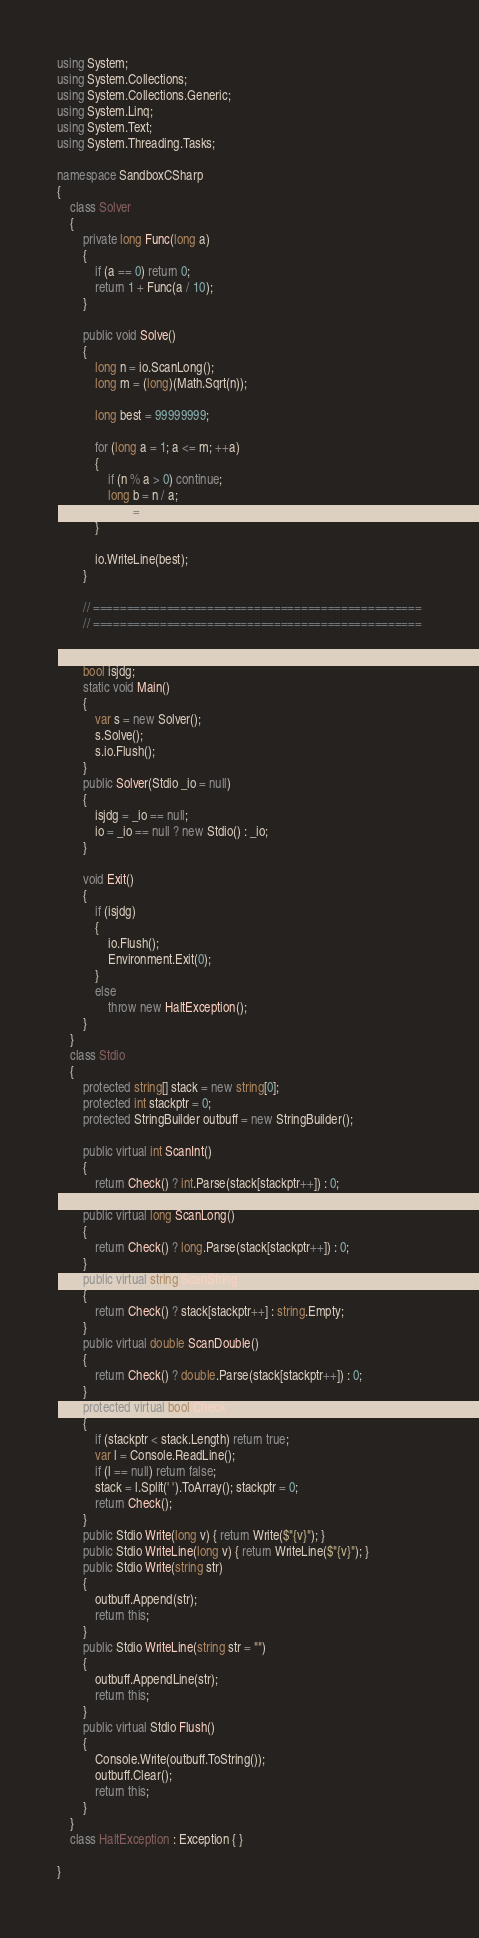<code> <loc_0><loc_0><loc_500><loc_500><_C#_>using System;
using System.Collections;
using System.Collections.Generic;
using System.Linq;
using System.Text;
using System.Threading.Tasks;

namespace SandboxCSharp
{
    class Solver
    {
        private long Func(long a)
        {
            if (a == 0) return 0;
            return 1 + Func(a / 10);
        }

        public void Solve()
        {
            long n = io.ScanLong();
            long m = (long)(Math.Sqrt(n));

            long best = 99999999;

            for (long a = 1; a <= m; ++a)
            {
                if (n % a > 0) continue;
                long b = n / a;
                best = Math.Min(best, Math.Max(Func(a), Func(b)));
            }

            io.WriteLine(best);
        }

        // =================================================
        // =================================================

        Stdio io;
        bool isjdg;
        static void Main()
        {
            var s = new Solver();
            s.Solve();
            s.io.Flush();
        }
        public Solver(Stdio _io = null)
        {
            isjdg = _io == null;
            io = _io == null ? new Stdio() : _io;
        }

        void Exit()
        {
            if (isjdg)
            {
                io.Flush();
                Environment.Exit(0);
            }
            else
                throw new HaltException();
        }
    }
    class Stdio
    {
        protected string[] stack = new string[0];
        protected int stackptr = 0;
        protected StringBuilder outbuff = new StringBuilder();

        public virtual int ScanInt()
        {
            return Check() ? int.Parse(stack[stackptr++]) : 0;
        }
        public virtual long ScanLong()
        {
            return Check() ? long.Parse(stack[stackptr++]) : 0;
        }
        public virtual string ScanString()
        {
            return Check() ? stack[stackptr++] : string.Empty;
        }
        public virtual double ScanDouble()
        {
            return Check() ? double.Parse(stack[stackptr++]) : 0;
        }
        protected virtual bool Check()
        {
            if (stackptr < stack.Length) return true;
            var l = Console.ReadLine();
            if (l == null) return false;
            stack = l.Split(' ').ToArray(); stackptr = 0;
            return Check();
        }
        public Stdio Write(long v) { return Write($"{v}"); }
        public Stdio WriteLine(long v) { return WriteLine($"{v}"); }
        public Stdio Write(string str)
        {
            outbuff.Append(str);
            return this;
        }
        public Stdio WriteLine(string str = "")
        {
            outbuff.AppendLine(str);
            return this;
        }
        public virtual Stdio Flush()
        {
            Console.Write(outbuff.ToString());
            outbuff.Clear();
            return this;
        }
    }
    class HaltException : Exception { }

}
</code> 